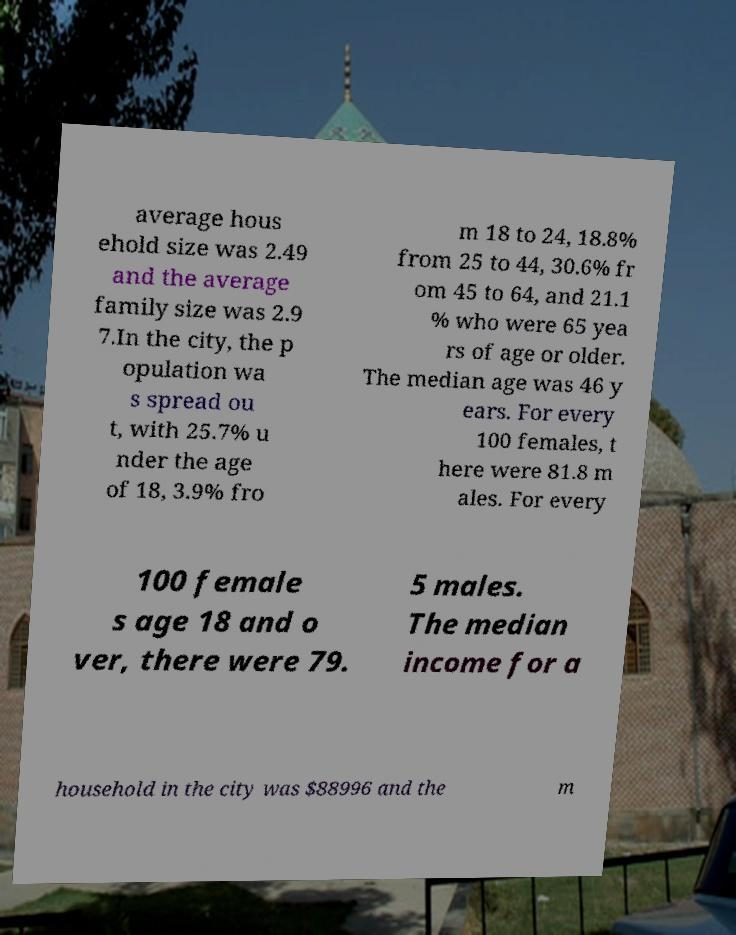What messages or text are displayed in this image? I need them in a readable, typed format. average hous ehold size was 2.49 and the average family size was 2.9 7.In the city, the p opulation wa s spread ou t, with 25.7% u nder the age of 18, 3.9% fro m 18 to 24, 18.8% from 25 to 44, 30.6% fr om 45 to 64, and 21.1 % who were 65 yea rs of age or older. The median age was 46 y ears. For every 100 females, t here were 81.8 m ales. For every 100 female s age 18 and o ver, there were 79. 5 males. The median income for a household in the city was $88996 and the m 